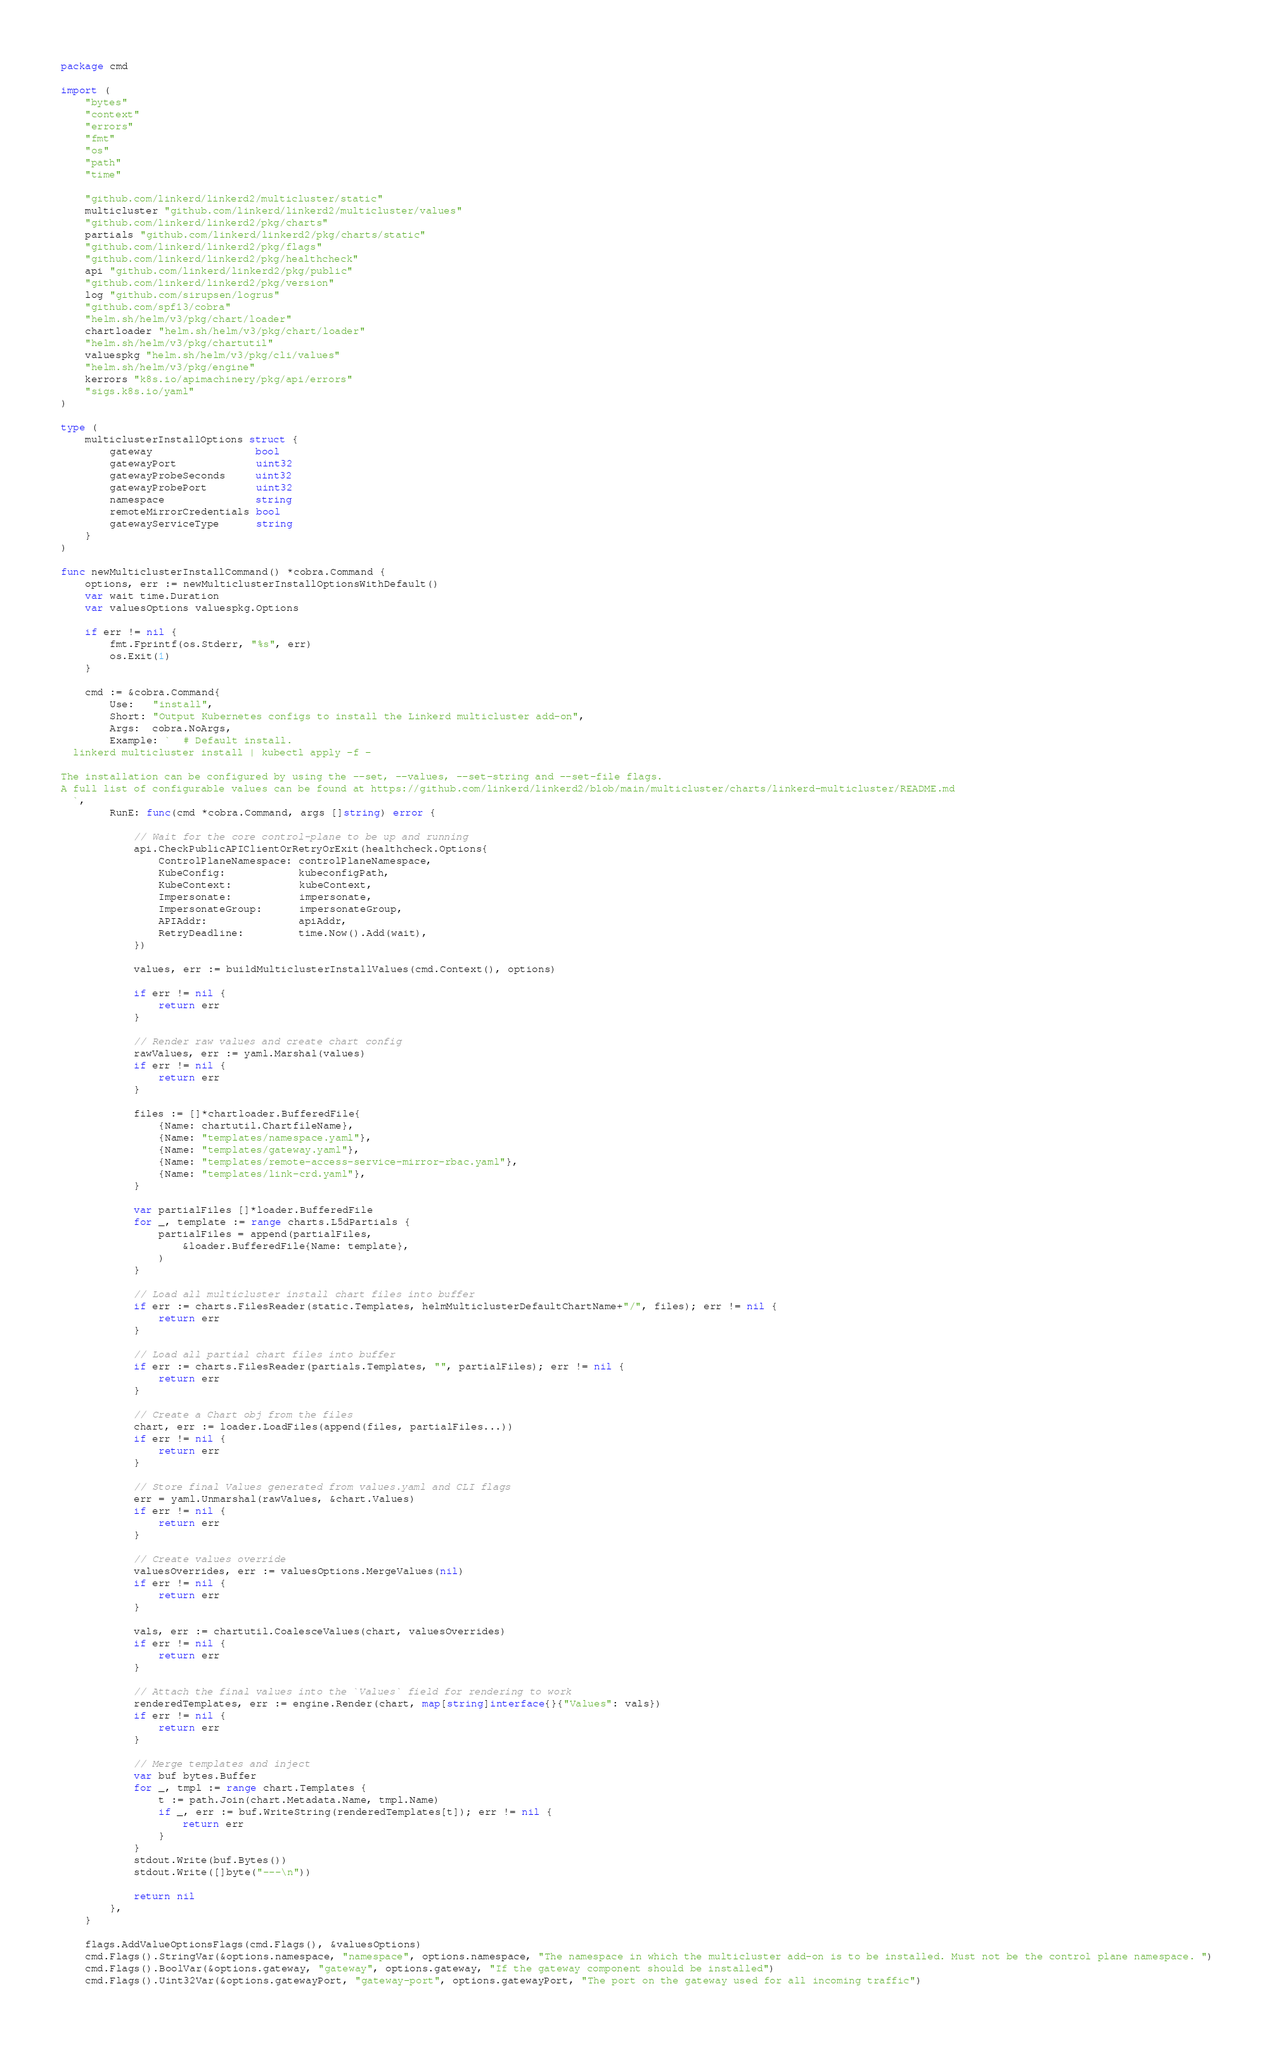Convert code to text. <code><loc_0><loc_0><loc_500><loc_500><_Go_>package cmd

import (
	"bytes"
	"context"
	"errors"
	"fmt"
	"os"
	"path"
	"time"

	"github.com/linkerd/linkerd2/multicluster/static"
	multicluster "github.com/linkerd/linkerd2/multicluster/values"
	"github.com/linkerd/linkerd2/pkg/charts"
	partials "github.com/linkerd/linkerd2/pkg/charts/static"
	"github.com/linkerd/linkerd2/pkg/flags"
	"github.com/linkerd/linkerd2/pkg/healthcheck"
	api "github.com/linkerd/linkerd2/pkg/public"
	"github.com/linkerd/linkerd2/pkg/version"
	log "github.com/sirupsen/logrus"
	"github.com/spf13/cobra"
	"helm.sh/helm/v3/pkg/chart/loader"
	chartloader "helm.sh/helm/v3/pkg/chart/loader"
	"helm.sh/helm/v3/pkg/chartutil"
	valuespkg "helm.sh/helm/v3/pkg/cli/values"
	"helm.sh/helm/v3/pkg/engine"
	kerrors "k8s.io/apimachinery/pkg/api/errors"
	"sigs.k8s.io/yaml"
)

type (
	multiclusterInstallOptions struct {
		gateway                 bool
		gatewayPort             uint32
		gatewayProbeSeconds     uint32
		gatewayProbePort        uint32
		namespace               string
		remoteMirrorCredentials bool
		gatewayServiceType      string
	}
)

func newMulticlusterInstallCommand() *cobra.Command {
	options, err := newMulticlusterInstallOptionsWithDefault()
	var wait time.Duration
	var valuesOptions valuespkg.Options

	if err != nil {
		fmt.Fprintf(os.Stderr, "%s", err)
		os.Exit(1)
	}

	cmd := &cobra.Command{
		Use:   "install",
		Short: "Output Kubernetes configs to install the Linkerd multicluster add-on",
		Args:  cobra.NoArgs,
		Example: `  # Default install.
  linkerd multicluster install | kubectl apply -f -
  
The installation can be configured by using the --set, --values, --set-string and --set-file flags.
A full list of configurable values can be found at https://github.com/linkerd/linkerd2/blob/main/multicluster/charts/linkerd-multicluster/README.md
  `,
		RunE: func(cmd *cobra.Command, args []string) error {

			// Wait for the core control-plane to be up and running
			api.CheckPublicAPIClientOrRetryOrExit(healthcheck.Options{
				ControlPlaneNamespace: controlPlaneNamespace,
				KubeConfig:            kubeconfigPath,
				KubeContext:           kubeContext,
				Impersonate:           impersonate,
				ImpersonateGroup:      impersonateGroup,
				APIAddr:               apiAddr,
				RetryDeadline:         time.Now().Add(wait),
			})

			values, err := buildMulticlusterInstallValues(cmd.Context(), options)

			if err != nil {
				return err
			}

			// Render raw values and create chart config
			rawValues, err := yaml.Marshal(values)
			if err != nil {
				return err
			}

			files := []*chartloader.BufferedFile{
				{Name: chartutil.ChartfileName},
				{Name: "templates/namespace.yaml"},
				{Name: "templates/gateway.yaml"},
				{Name: "templates/remote-access-service-mirror-rbac.yaml"},
				{Name: "templates/link-crd.yaml"},
			}

			var partialFiles []*loader.BufferedFile
			for _, template := range charts.L5dPartials {
				partialFiles = append(partialFiles,
					&loader.BufferedFile{Name: template},
				)
			}

			// Load all multicluster install chart files into buffer
			if err := charts.FilesReader(static.Templates, helmMulticlusterDefaultChartName+"/", files); err != nil {
				return err
			}

			// Load all partial chart files into buffer
			if err := charts.FilesReader(partials.Templates, "", partialFiles); err != nil {
				return err
			}

			// Create a Chart obj from the files
			chart, err := loader.LoadFiles(append(files, partialFiles...))
			if err != nil {
				return err
			}

			// Store final Values generated from values.yaml and CLI flags
			err = yaml.Unmarshal(rawValues, &chart.Values)
			if err != nil {
				return err
			}

			// Create values override
			valuesOverrides, err := valuesOptions.MergeValues(nil)
			if err != nil {
				return err
			}

			vals, err := chartutil.CoalesceValues(chart, valuesOverrides)
			if err != nil {
				return err
			}

			// Attach the final values into the `Values` field for rendering to work
			renderedTemplates, err := engine.Render(chart, map[string]interface{}{"Values": vals})
			if err != nil {
				return err
			}

			// Merge templates and inject
			var buf bytes.Buffer
			for _, tmpl := range chart.Templates {
				t := path.Join(chart.Metadata.Name, tmpl.Name)
				if _, err := buf.WriteString(renderedTemplates[t]); err != nil {
					return err
				}
			}
			stdout.Write(buf.Bytes())
			stdout.Write([]byte("---\n"))

			return nil
		},
	}

	flags.AddValueOptionsFlags(cmd.Flags(), &valuesOptions)
	cmd.Flags().StringVar(&options.namespace, "namespace", options.namespace, "The namespace in which the multicluster add-on is to be installed. Must not be the control plane namespace. ")
	cmd.Flags().BoolVar(&options.gateway, "gateway", options.gateway, "If the gateway component should be installed")
	cmd.Flags().Uint32Var(&options.gatewayPort, "gateway-port", options.gatewayPort, "The port on the gateway used for all incoming traffic")</code> 